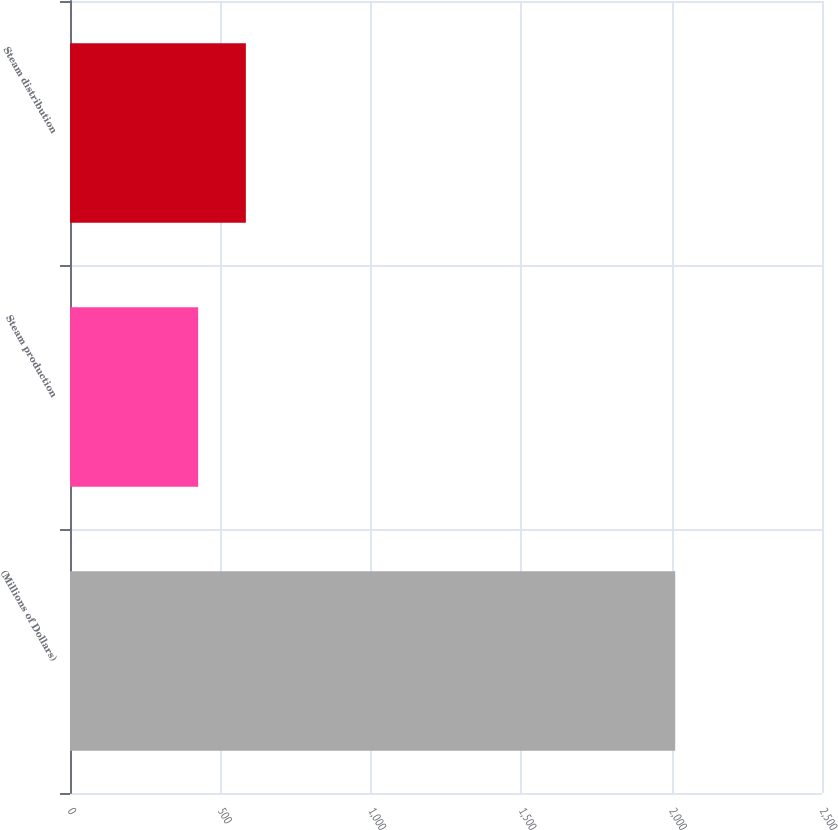<chart> <loc_0><loc_0><loc_500><loc_500><bar_chart><fcel>(Millions of Dollars)<fcel>Steam production<fcel>Steam distribution<nl><fcel>2012<fcel>426<fcel>584.6<nl></chart> 